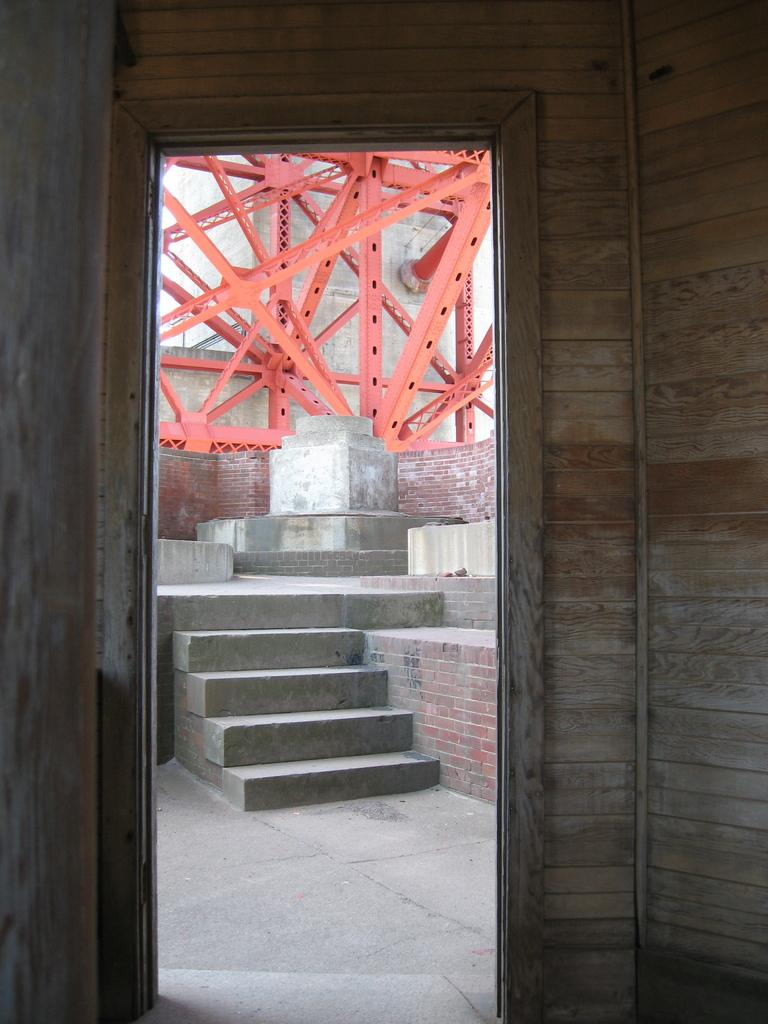What is a prominent feature in the image? There is a door in the image. What architectural element is present in the image? There are stairs in the image. Where are the stairs located in relation to the image? The stairs are at the back side of the image. What is on top of the stairs in the image? There is a metal structure on top of the stairs. How many pens are visible on the door in the image? There are no pens visible on the door in the image. 